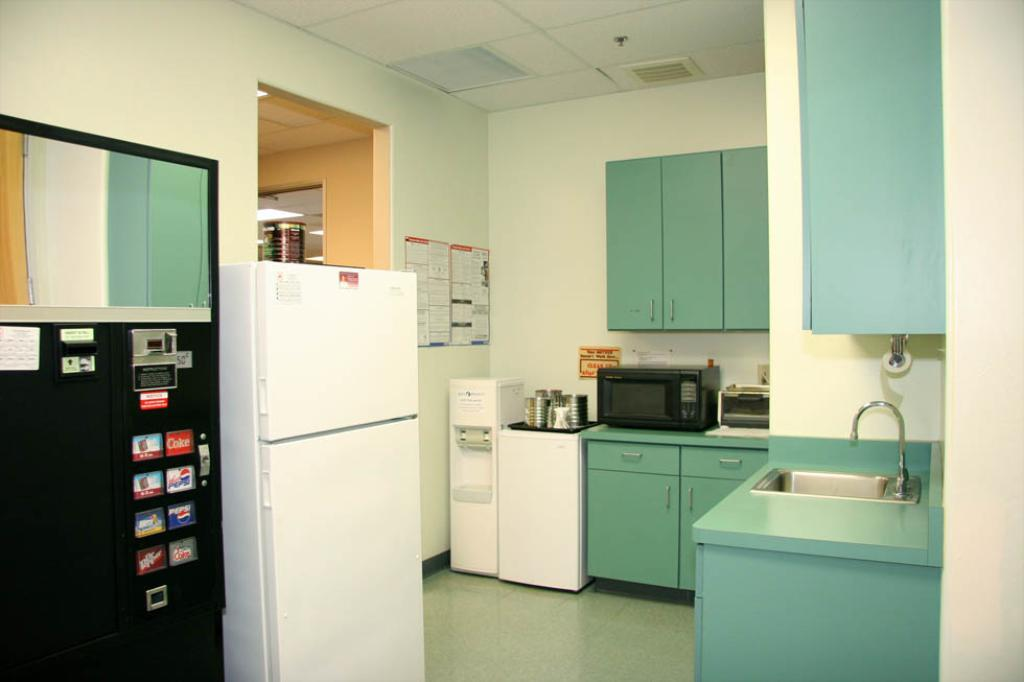<image>
Create a compact narrative representing the image presented. A vending machine contains options like Dr. Pepper, Pepsi and Coke. 